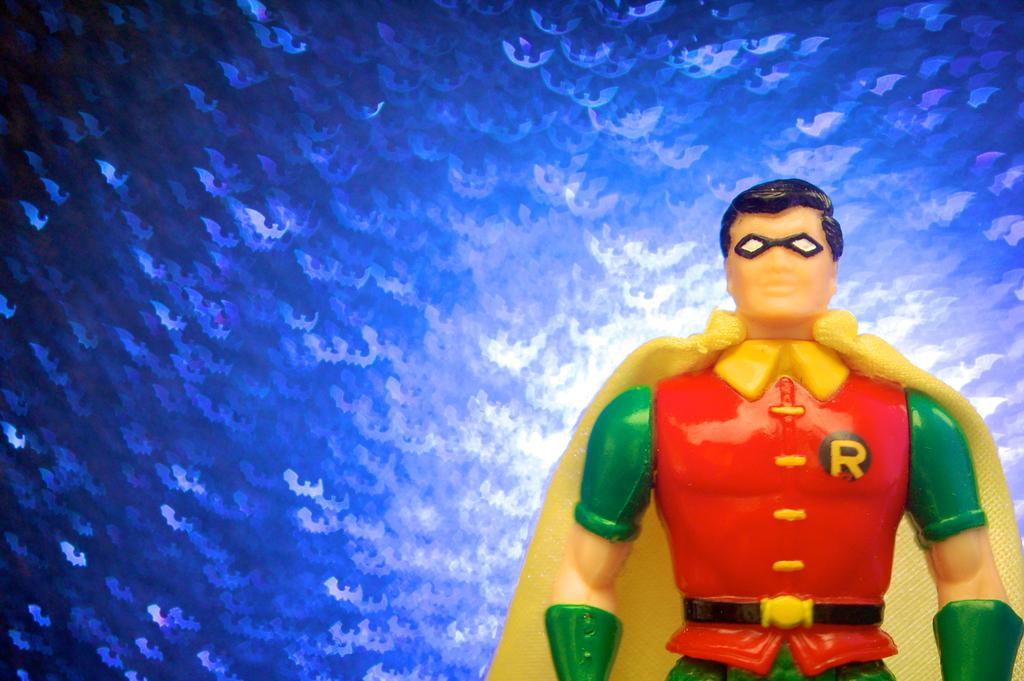What is the main object in the image? There is a toy in the image. Can you describe the toy's appearance? The toy has a red, green, and yellow colored dress. What color is the background of the image? The background of the image is blue. What type of silver material is used to make the toy's dress in the image? The toy's dress is not made of silver; it is described as having red, green, and yellow colors. How does the sleet affect the toy in the image? There is no mention of sleet in the image, so it cannot affect the toy. 